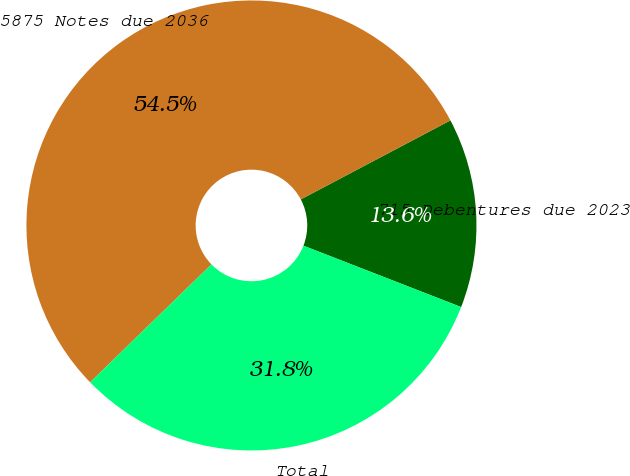Convert chart. <chart><loc_0><loc_0><loc_500><loc_500><pie_chart><fcel>715 Debentures due 2023<fcel>5875 Notes due 2036<fcel>Total<nl><fcel>13.64%<fcel>54.55%<fcel>31.82%<nl></chart> 